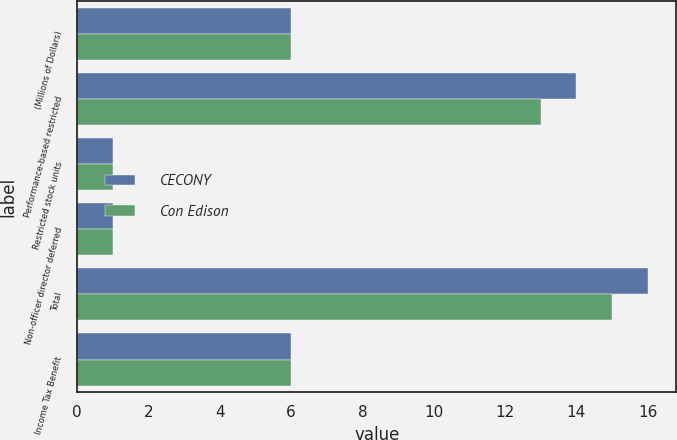Convert chart to OTSL. <chart><loc_0><loc_0><loc_500><loc_500><stacked_bar_chart><ecel><fcel>(Millions of Dollars)<fcel>Performance-based restricted<fcel>Restricted stock units<fcel>Non-officer director deferred<fcel>Total<fcel>Income Tax Benefit<nl><fcel>CECONY<fcel>6<fcel>14<fcel>1<fcel>1<fcel>16<fcel>6<nl><fcel>Con Edison<fcel>6<fcel>13<fcel>1<fcel>1<fcel>15<fcel>6<nl></chart> 